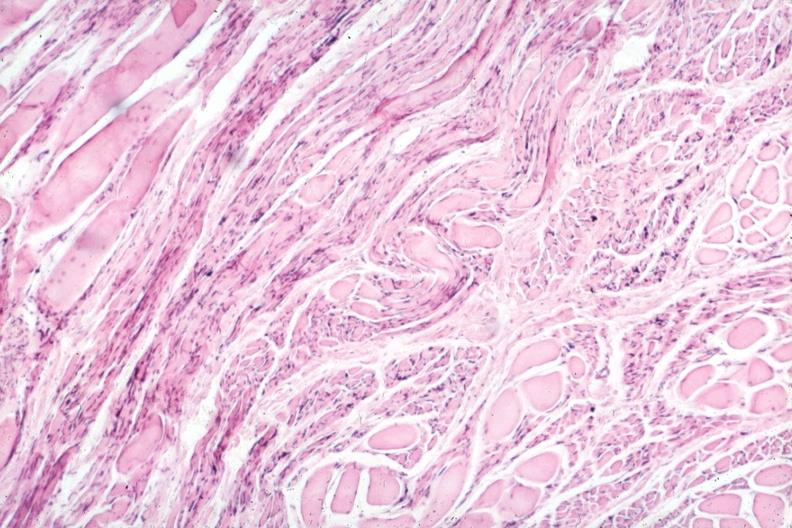s endocervical polyp present?
Answer the question using a single word or phrase. No 